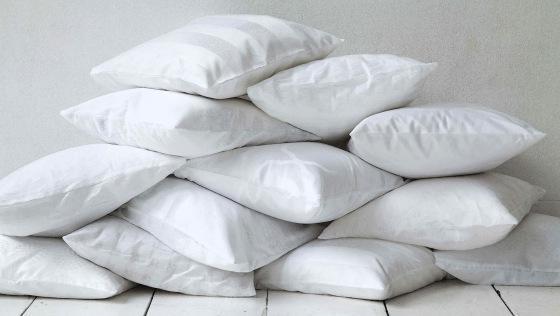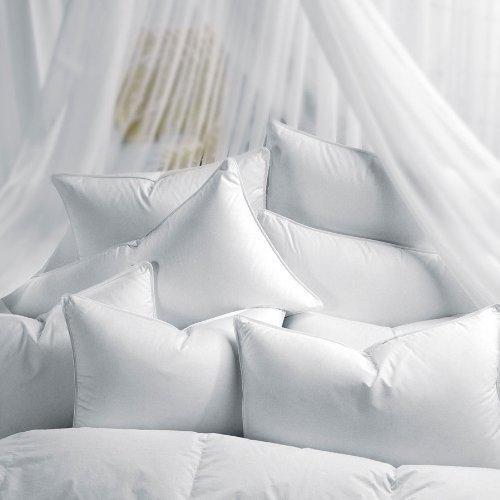The first image is the image on the left, the second image is the image on the right. For the images displayed, is the sentence "In one image a roll pillow with tan stripes is in front of white rectangular upright bed billows." factually correct? Answer yes or no. No. The first image is the image on the left, the second image is the image on the right. Analyze the images presented: Is the assertion "An image includes a cylindrical pillow with beige bands on each end." valid? Answer yes or no. No. 